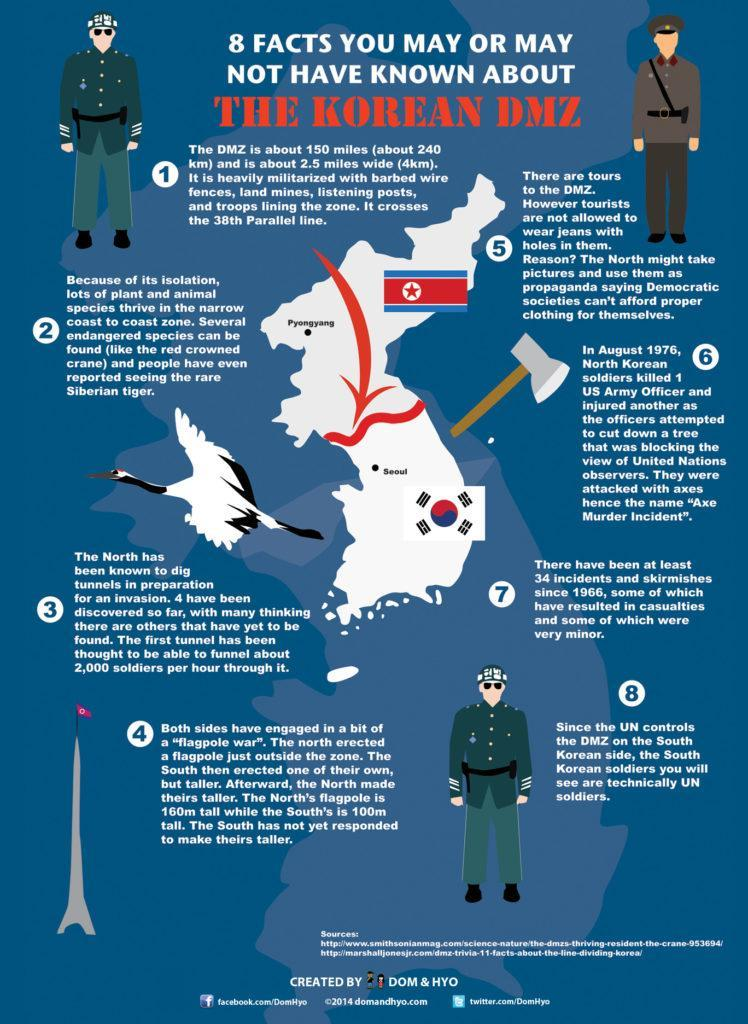How many confrontations have occurred at the DMZ since 1966?
Answer the question with a short phrase. 34 What are tourists in DMZ restricted from wearing? Jeans with holes in them Which latitude does the DMZ cross? 38th parallel line What is the capacity of the first tunnel on the Northern side? 2000 soldiers per hour By how much is the North's flagpole taller than the South's flagpole(m)? 60 When did the 'Axe Murder Incident' occur and who was killed in it? August 1976, US army officer Whose flagpole is taller, North Korea or South Korea ? North Korea What has now become a home to some endangered species? DMZ Who attacked the US officers in the Axe murder incident? North Korean soldiers What is the length and width of the DMZ(km)? 240, 4 Which side of the DMZ is controlled by the UN? South Korean side How many tunnels have been discovered on the Northern side of the DMZ? 4 What was the weapon used in the 'Axe Murder Incident'? Axe Which are the two endangered species spotted in the DMZ? Red crowned crane, Siberian tiger 